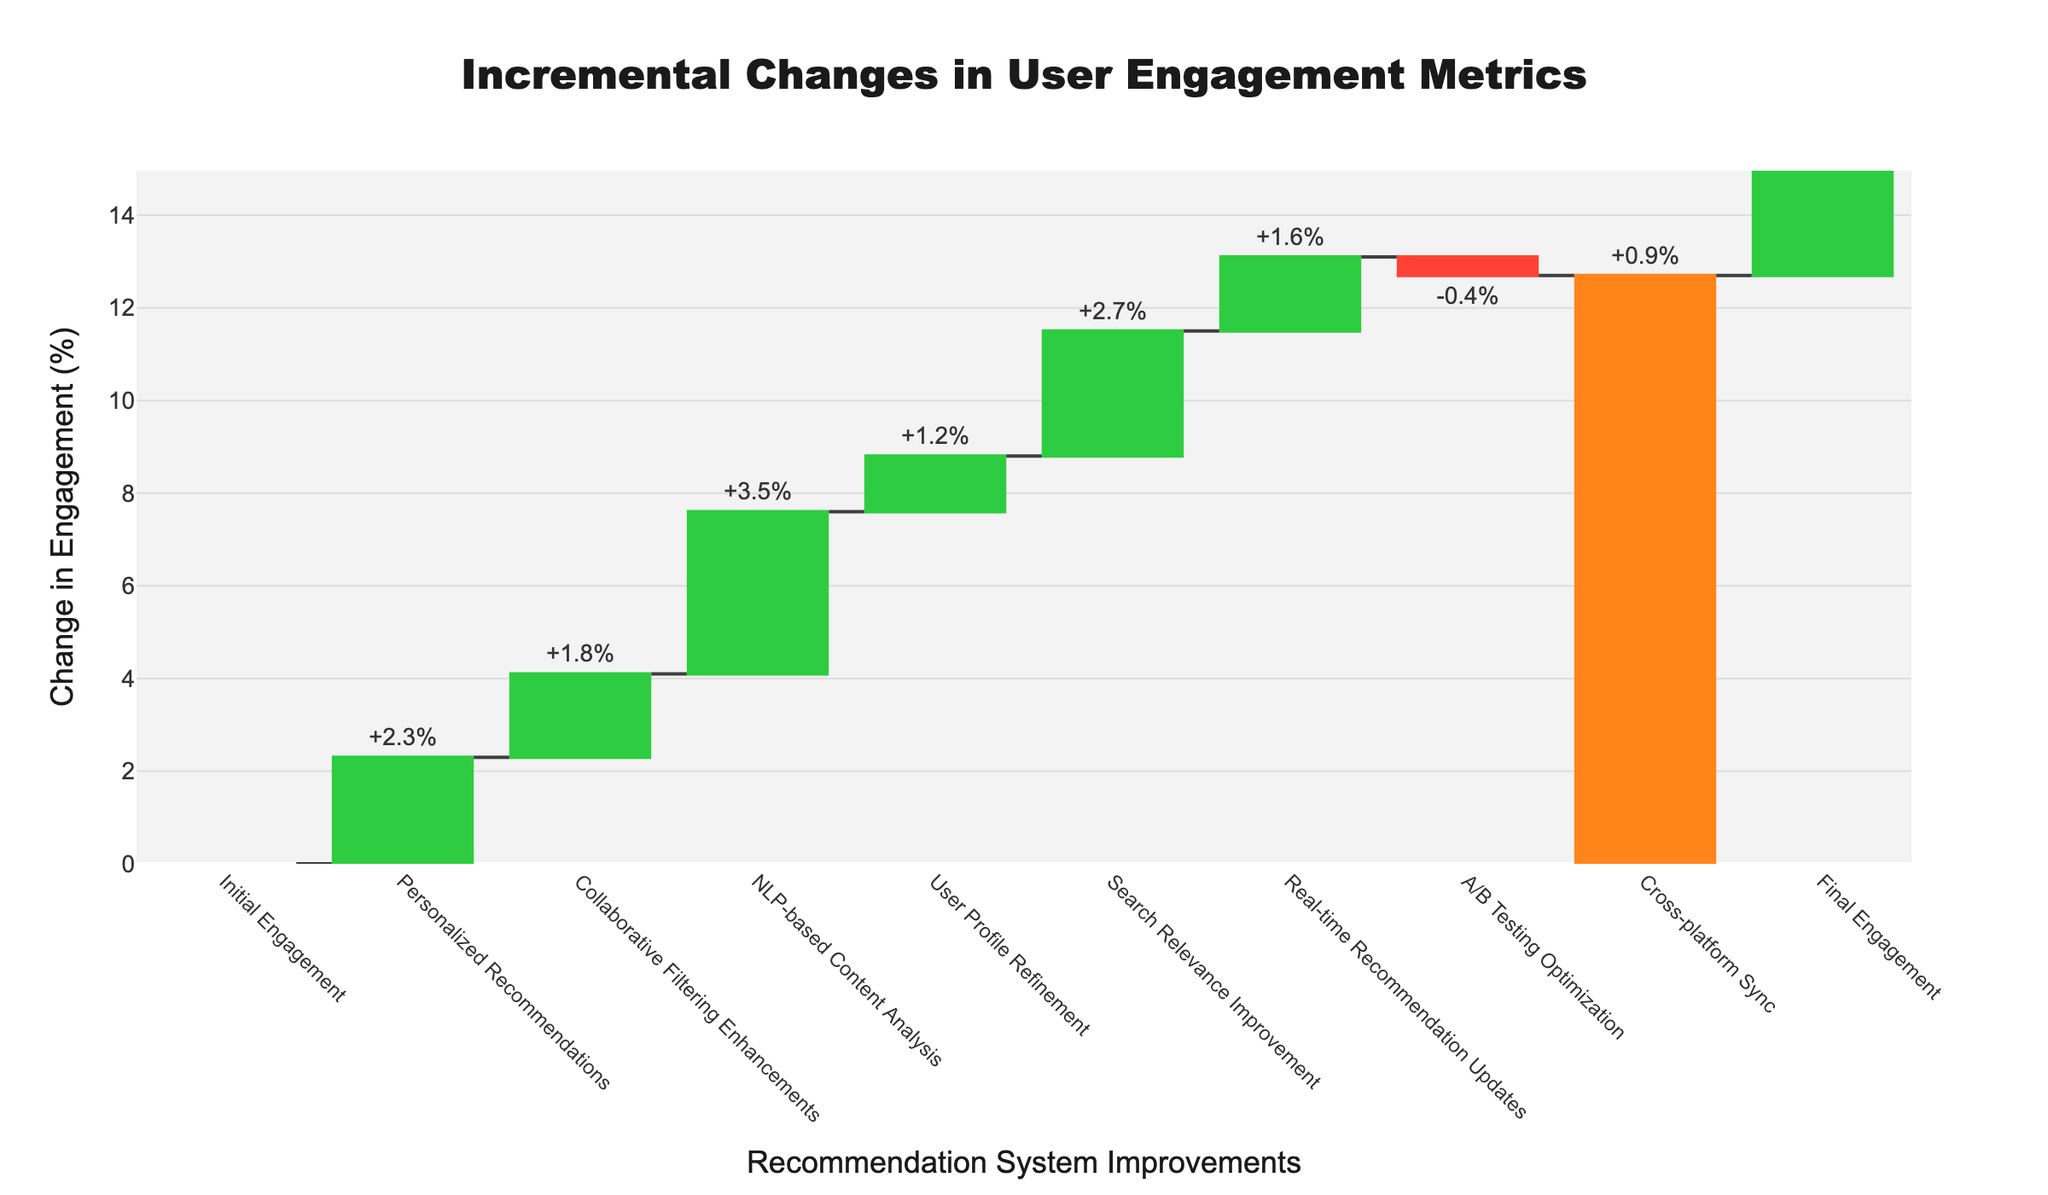What is the title of the chart? The title of the chart is located at the top and is usually the largest text on the figure. In this chart, it states the main purpose of the visualization.
Answer: Incremental Changes in User Engagement Metrics What is the total change in user engagement by the end of the improvements? The total change is the final value indicated at the end of the waterfall chart, which sums all incremental changes. This is labeled "Final Engagement."
Answer: 13.6% Which improvement led to the largest increase in user engagement? Look for the bar with the largest positive value. The bars are labeled with categories and change values. The largest positive bar represents the biggest increase.
Answer: NLP-based Content Analysis What is the change in user engagement due to A/B Testing Optimization? Identify the bar labeled "A/B Testing Optimization" and note the associated change value. In this case, it is a negative value.
Answer: -0.4% By how much did the user engagement increase after implementing Personalized Recommendations and Collaborative Filtering Enhancements combined? Sum the changes from "Personalized Recommendations" (+2.3) and "Collaborative Filtering Enhancements" (+1.8).
Answer: 4.1% Which improvement contributed less to the user engagement compared to Search Relevance Improvement? Compare the change values associated with each category. The categories with smaller increases than Search Relevance Improvement (+2.7) are candidates.
Answer: User Profile Refinement What is the total increase in user engagement from Personalized Recommendations, Collaborative Filtering Enhancements, and NLP-based Content Analysis? Add the changes from each of the three improvements: +2.3, +1.8, and +3.5.
Answer: 7.6% How does the improvement from Search Relevance Improvement compare to Real-time Recommendation Updates? Compare the change values of the two improvements which are +2.7 and +1.6 respectively. Determine if one is greater than the other.
Answer: Search Relevance Improvement is greater What changes decreased user engagement in this figure? Identify the bars with negative values. Only those will correspond to decreases in user engagement.
Answer: A/B Testing Optimization How much additional engagement was gained from all improvements except A/B Testing Optimization? Exclude the change from A/B Testing Optimization and sum the remaining changes: +2.3 +1.8 +3.5 +1.2 +2.7 +1.6 +0.9.
Answer: 14.0% 